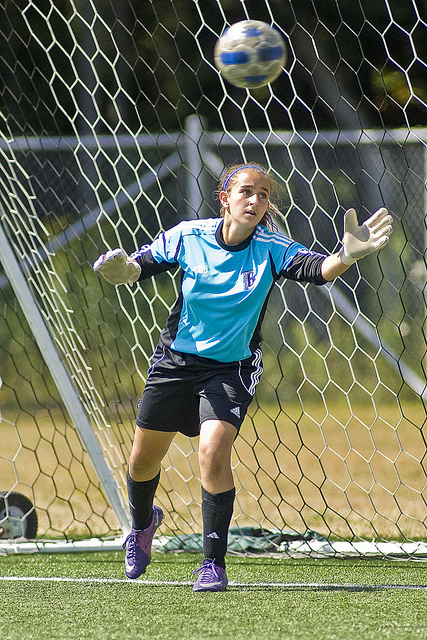Please transcribe the text information in this image. B 